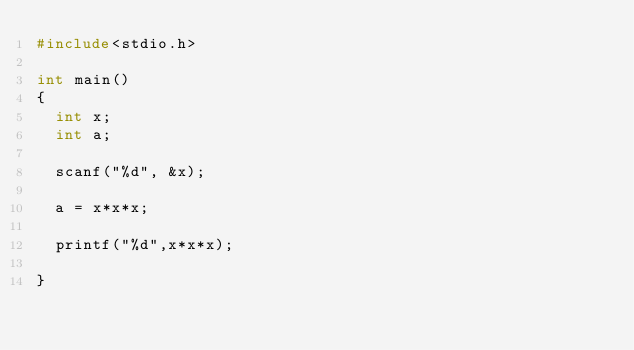<code> <loc_0><loc_0><loc_500><loc_500><_C_>#include<stdio.h>

int main()
{
	int x;
	int a;

	scanf("%d", &x);

	a = x*x*x;

	printf("%d",x*x*x);

}</code> 